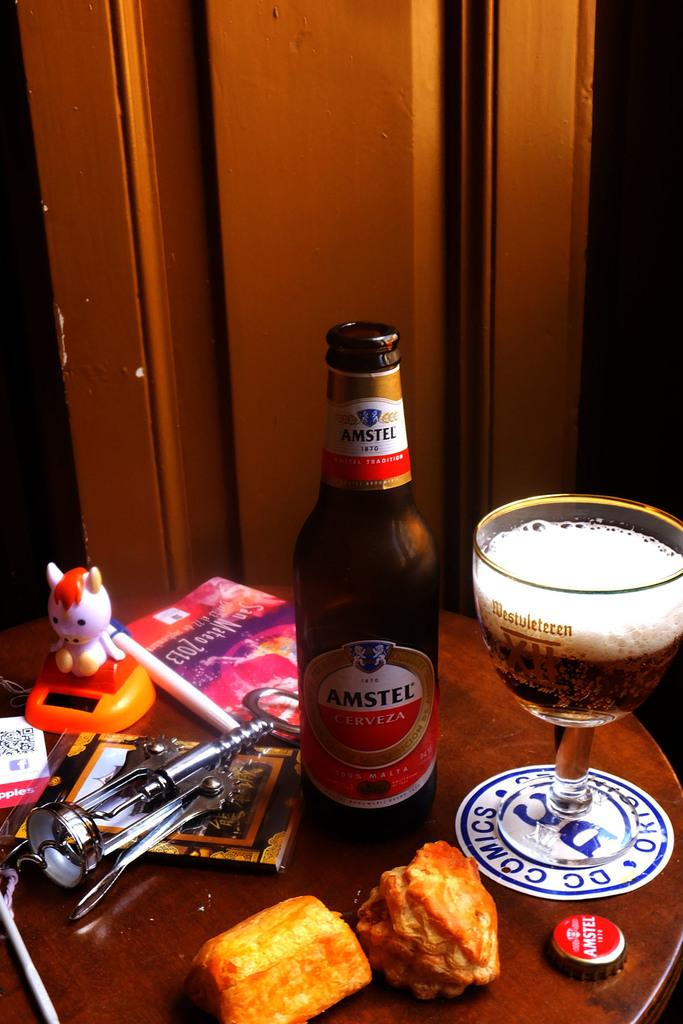<image>
Provide a brief description of the given image. Bottle of Amstel beer next to a cup of beer on top of a messy table. 